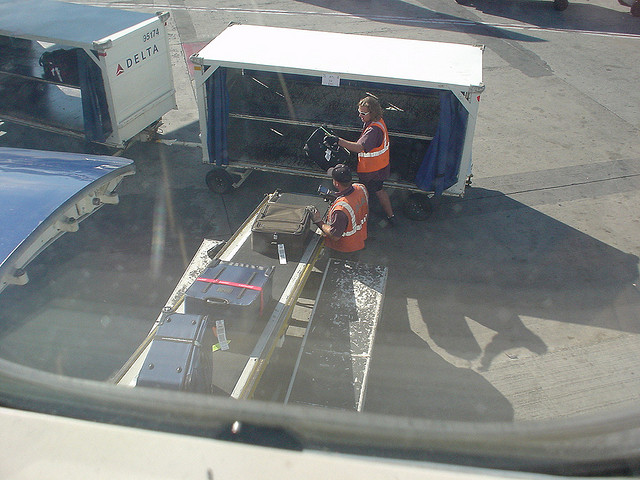Read all the text in this image. DELTA 95174 